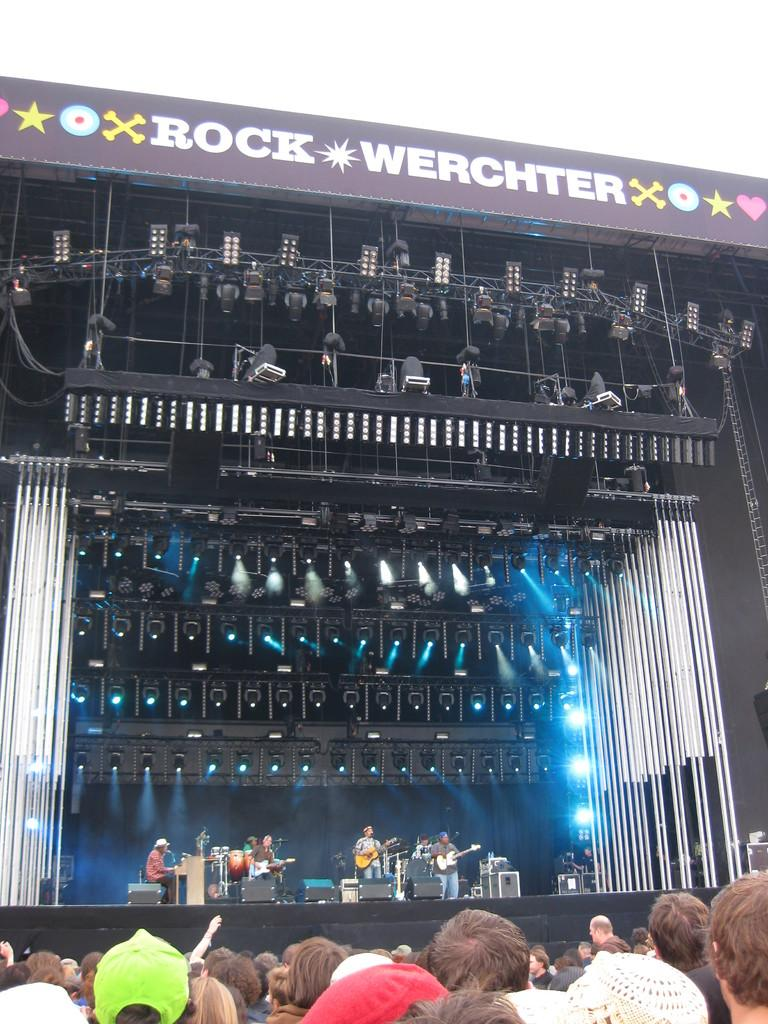What is happening in the image? A concert is taking place. Are there any people involved in the event? Yes, people are present at the concert. What are the people on stage doing? People are performing on stage. What are the performers using to create music? Musical instruments are being played. Can you describe the lighting at the concert? There are lights at the concert. Is there any additional information provided about the event or location? There is a board on top, possibly indicating the event or location. Can you tell me how many bells are hanging from the ceiling at the concert? There is no mention of bells in the image, so it is not possible to determine their presence or quantity. 